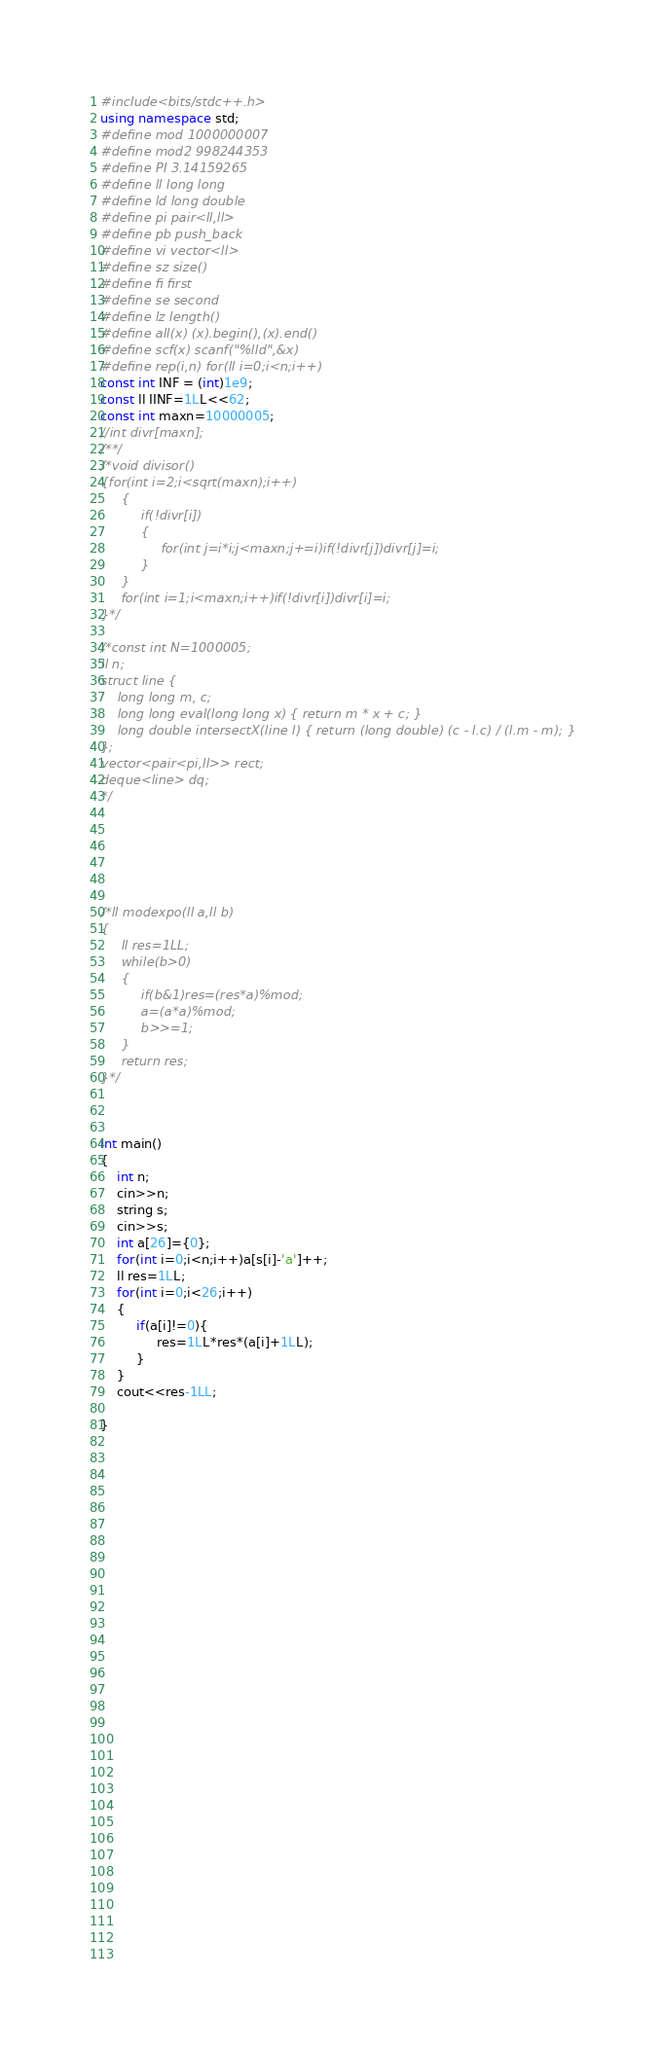Convert code to text. <code><loc_0><loc_0><loc_500><loc_500><_C++_>#include<bits/stdc++.h>
using namespace std;
#define mod 1000000007
#define mod2 998244353 
#define PI 3.14159265
#define ll long long
#define ld long double
#define pi pair<ll,ll>
#define pb push_back
#define vi vector<ll>
#define sz size()
#define fi first
#define se second
#define lz length()
#define all(x) (x).begin(),(x).end()
#define scf(x) scanf("%lld",&x)
#define rep(i,n) for(ll i=0;i<n;i++)
const int INF = (int)1e9;
const ll IINF=1LL<<62;
const int maxn=10000005;
//int divr[maxn];
/**/
/*void divisor()
{for(int i=2;i<sqrt(maxn);i++)
     {
          if(!divr[i])
          {
               for(int j=i*i;j<maxn;j+=i)if(!divr[j])divr[j]=i;     
          }
     }
     for(int i=1;i<maxn;i++)if(!divr[i])divr[i]=i;
}*/
 
/*const int N=1000005;
ll n;
struct line {
    long long m, c;
    long long eval(long long x) { return m * x + c; }
    long double intersectX(line l) { return (long double) (c - l.c) / (l.m - m); }
};
vector<pair<pi,ll>> rect;
deque<line> dq;
*/
 
 
 
 


/*ll modexpo(ll a,ll b)
{
     ll res=1LL;
     while(b>0)
     {
          if(b&1)res=(res*a)%mod;
          a=(a*a)%mod;
          b>>=1;
     }
     return res;
}*/



int main()
{
    int n;
    cin>>n;
    string s;
    cin>>s;
    int a[26]={0};
    for(int i=0;i<n;i++)a[s[i]-'a']++;
    ll res=1LL;
    for(int i=0;i<26;i++)
    {
         if(a[i]!=0){
              res=1LL*res*(a[i]+1LL);
         }
    }
    cout<<res-1LL;

}















 














 
 















</code> 